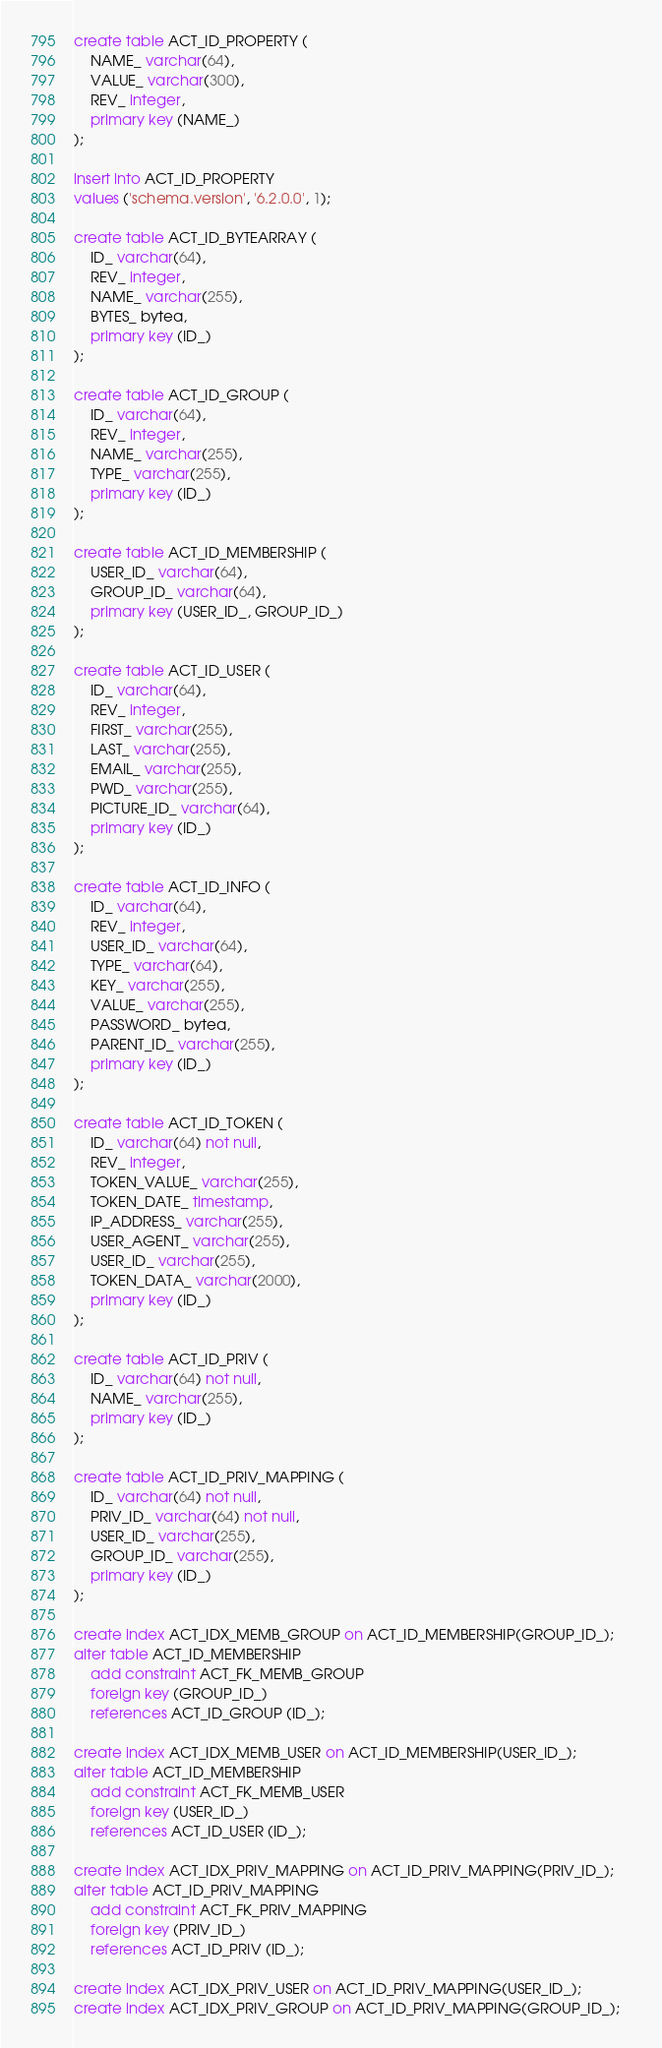Convert code to text. <code><loc_0><loc_0><loc_500><loc_500><_SQL_>create table ACT_ID_PROPERTY (
    NAME_ varchar(64),
    VALUE_ varchar(300),
    REV_ integer,
    primary key (NAME_)
);

insert into ACT_ID_PROPERTY
values ('schema.version', '6.2.0.0', 1);

create table ACT_ID_BYTEARRAY (
    ID_ varchar(64),
    REV_ integer,
    NAME_ varchar(255),
    BYTES_ bytea,
    primary key (ID_)
);

create table ACT_ID_GROUP (
    ID_ varchar(64),
    REV_ integer,
    NAME_ varchar(255),
    TYPE_ varchar(255),
    primary key (ID_)
);

create table ACT_ID_MEMBERSHIP (
    USER_ID_ varchar(64),
    GROUP_ID_ varchar(64),
    primary key (USER_ID_, GROUP_ID_)
);

create table ACT_ID_USER (
    ID_ varchar(64),
    REV_ integer,
    FIRST_ varchar(255),
    LAST_ varchar(255),
    EMAIL_ varchar(255),
    PWD_ varchar(255),
    PICTURE_ID_ varchar(64),
    primary key (ID_)
);

create table ACT_ID_INFO (
    ID_ varchar(64),
    REV_ integer,
    USER_ID_ varchar(64),
    TYPE_ varchar(64),
    KEY_ varchar(255),
    VALUE_ varchar(255),
    PASSWORD_ bytea,
    PARENT_ID_ varchar(255),
    primary key (ID_)
);

create table ACT_ID_TOKEN (
    ID_ varchar(64) not null,
    REV_ integer,
    TOKEN_VALUE_ varchar(255),
    TOKEN_DATE_ timestamp,
    IP_ADDRESS_ varchar(255),
    USER_AGENT_ varchar(255),
    USER_ID_ varchar(255),
    TOKEN_DATA_ varchar(2000),
    primary key (ID_)
);

create table ACT_ID_PRIV (
    ID_ varchar(64) not null,
    NAME_ varchar(255),
    primary key (ID_)
);

create table ACT_ID_PRIV_MAPPING (
    ID_ varchar(64) not null,
    PRIV_ID_ varchar(64) not null,
    USER_ID_ varchar(255),
    GROUP_ID_ varchar(255),
    primary key (ID_)
);

create index ACT_IDX_MEMB_GROUP on ACT_ID_MEMBERSHIP(GROUP_ID_);
alter table ACT_ID_MEMBERSHIP 
    add constraint ACT_FK_MEMB_GROUP
    foreign key (GROUP_ID_) 
    references ACT_ID_GROUP (ID_);

create index ACT_IDX_MEMB_USER on ACT_ID_MEMBERSHIP(USER_ID_);
alter table ACT_ID_MEMBERSHIP 
    add constraint ACT_FK_MEMB_USER
    foreign key (USER_ID_) 
    references ACT_ID_USER (ID_);

create index ACT_IDX_PRIV_MAPPING on ACT_ID_PRIV_MAPPING(PRIV_ID_);    
alter table ACT_ID_PRIV_MAPPING 
    add constraint ACT_FK_PRIV_MAPPING 
    foreign key (PRIV_ID_) 
    references ACT_ID_PRIV (ID_);
    
create index ACT_IDX_PRIV_USER on ACT_ID_PRIV_MAPPING(USER_ID_);
create index ACT_IDX_PRIV_GROUP on ACT_ID_PRIV_MAPPING(GROUP_ID_);   </code> 